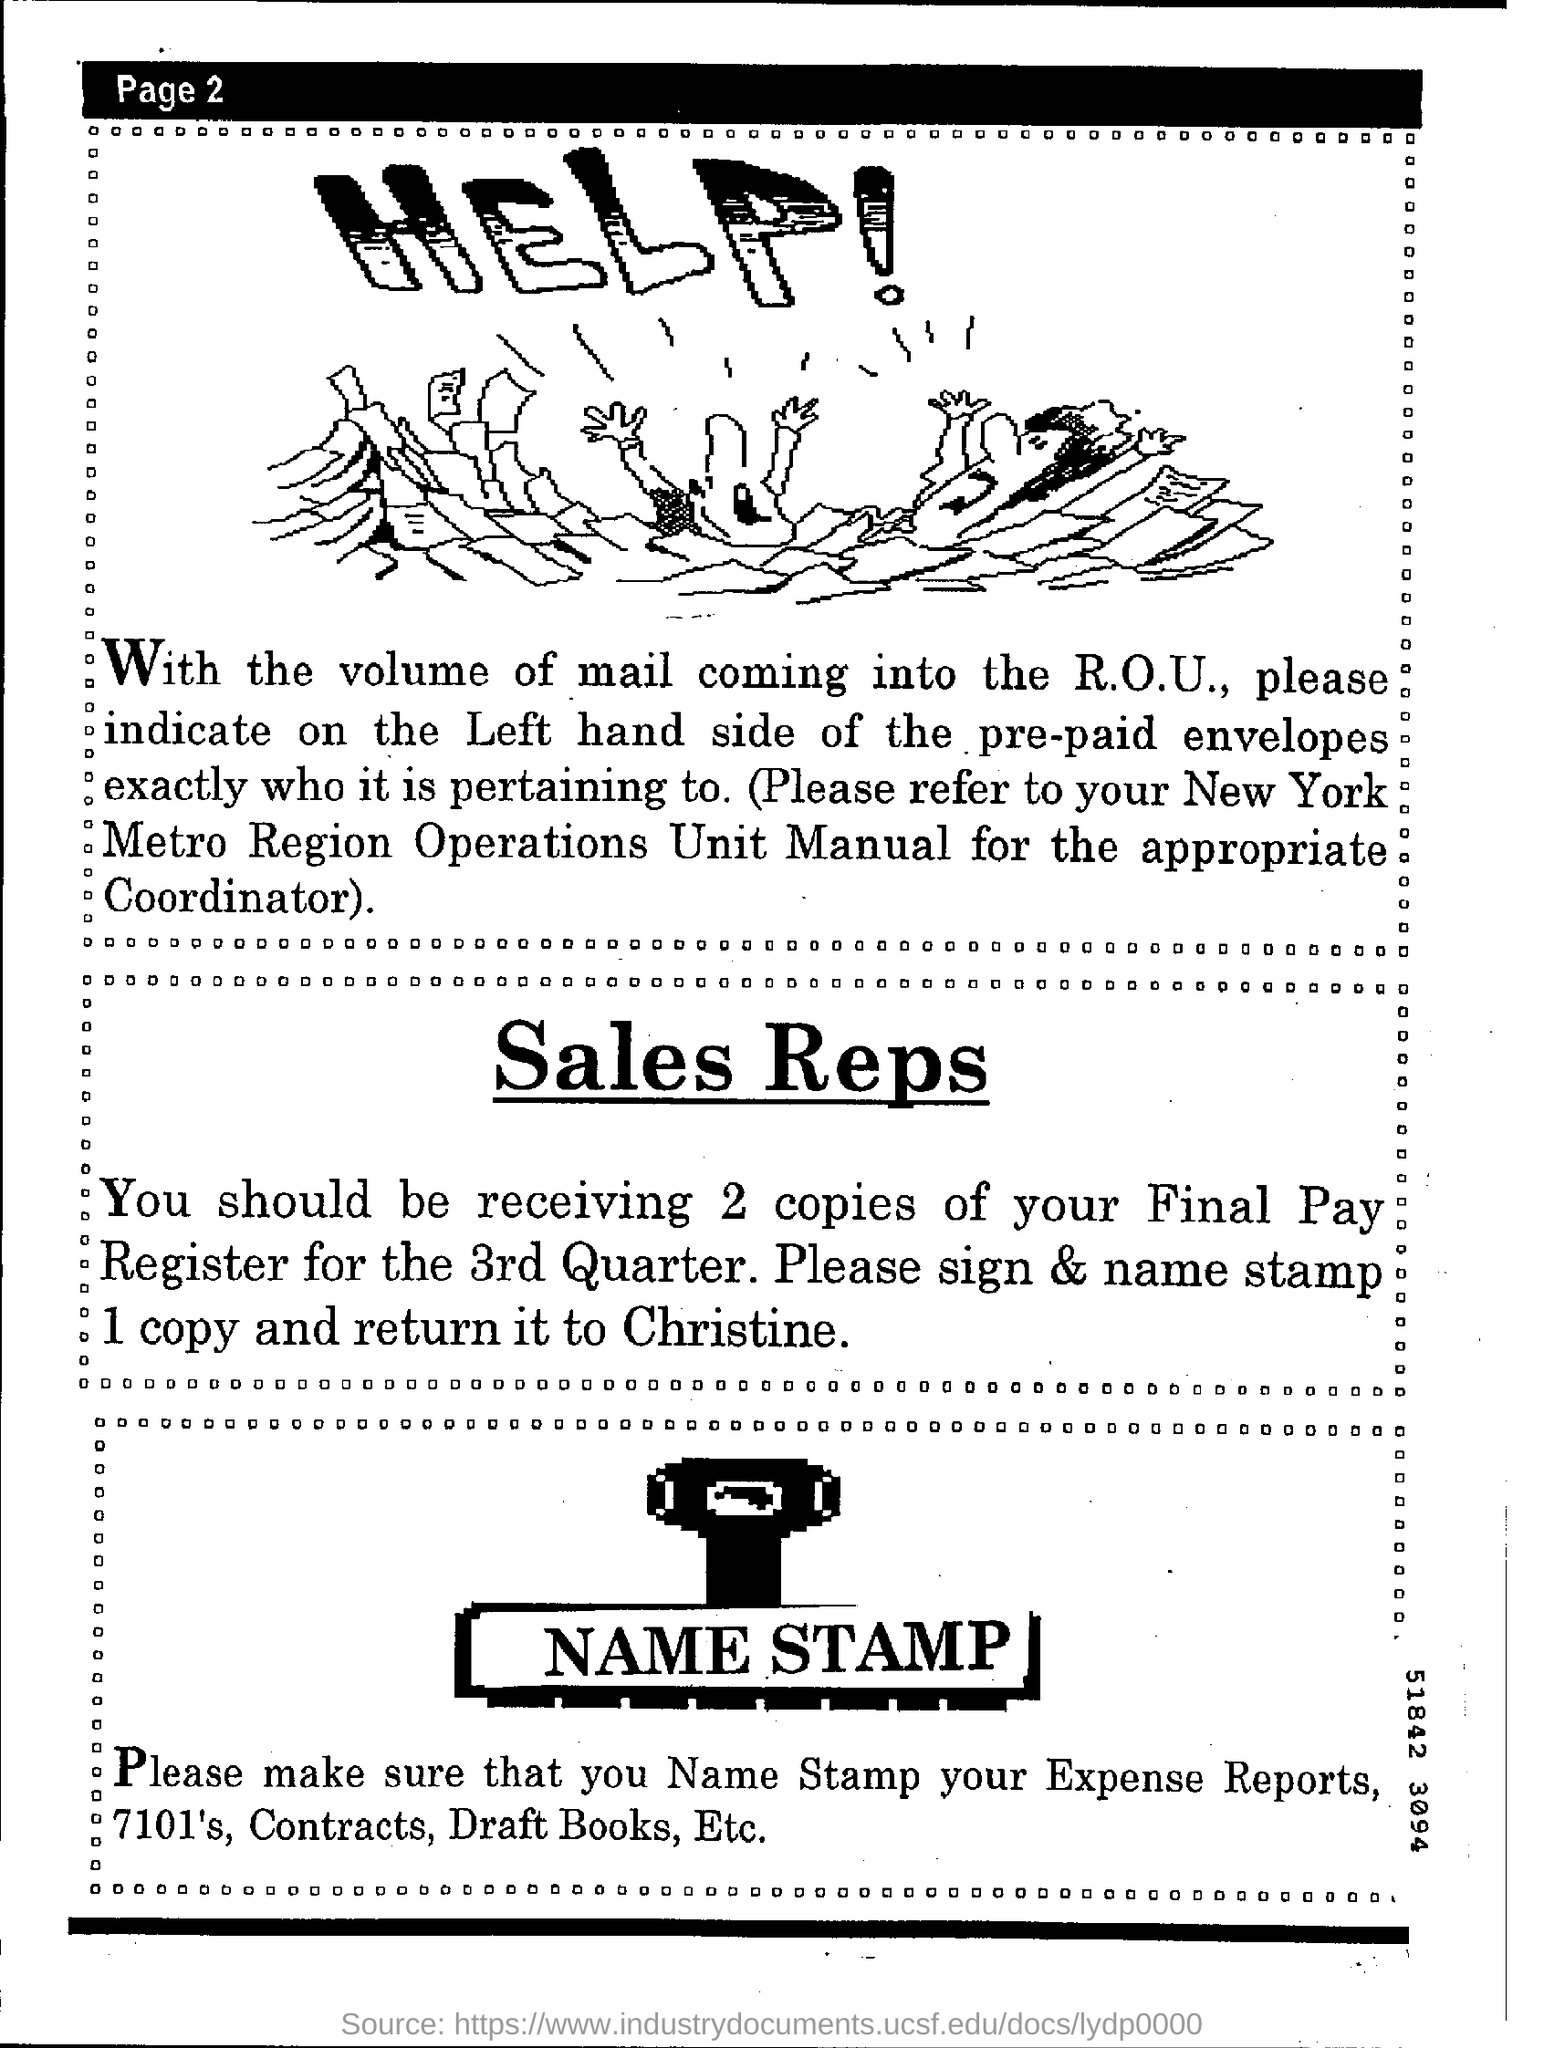Where should you name stamp?
Keep it short and to the point. Expense reports , 7101's , contracts , draft books etc. Where should you refer to for the appropriate coordinator?
Give a very brief answer. New York Metro Region Operations Unit Manual. To whom should you sign and name stamp 1 copy of final pay register for the 3rd quarter? ?
Make the answer very short. Christine. 